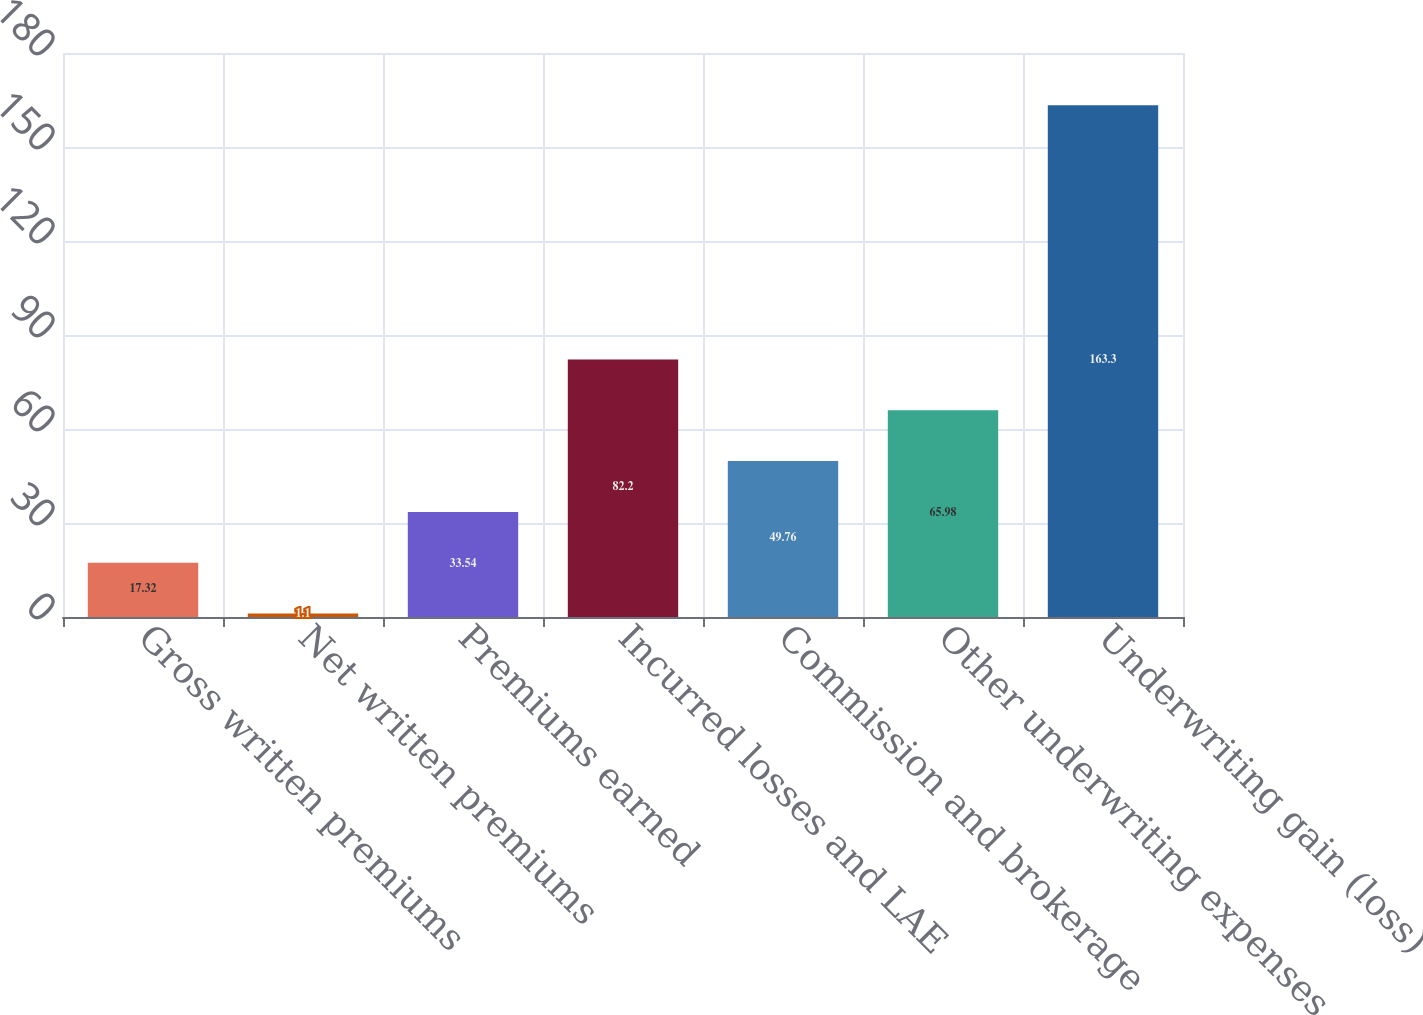Convert chart to OTSL. <chart><loc_0><loc_0><loc_500><loc_500><bar_chart><fcel>Gross written premiums<fcel>Net written premiums<fcel>Premiums earned<fcel>Incurred losses and LAE<fcel>Commission and brokerage<fcel>Other underwriting expenses<fcel>Underwriting gain (loss)<nl><fcel>17.32<fcel>1.1<fcel>33.54<fcel>82.2<fcel>49.76<fcel>65.98<fcel>163.3<nl></chart> 